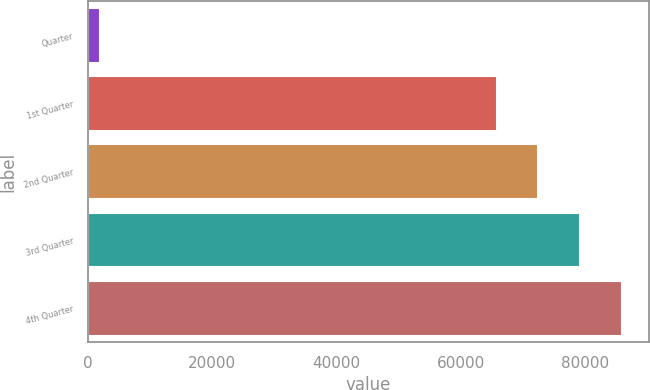Convert chart. <chart><loc_0><loc_0><loc_500><loc_500><bar_chart><fcel>Quarter<fcel>1st Quarter<fcel>2nd Quarter<fcel>3rd Quarter<fcel>4th Quarter<nl><fcel>2015<fcel>65800<fcel>72528.5<fcel>79257<fcel>85985.5<nl></chart> 